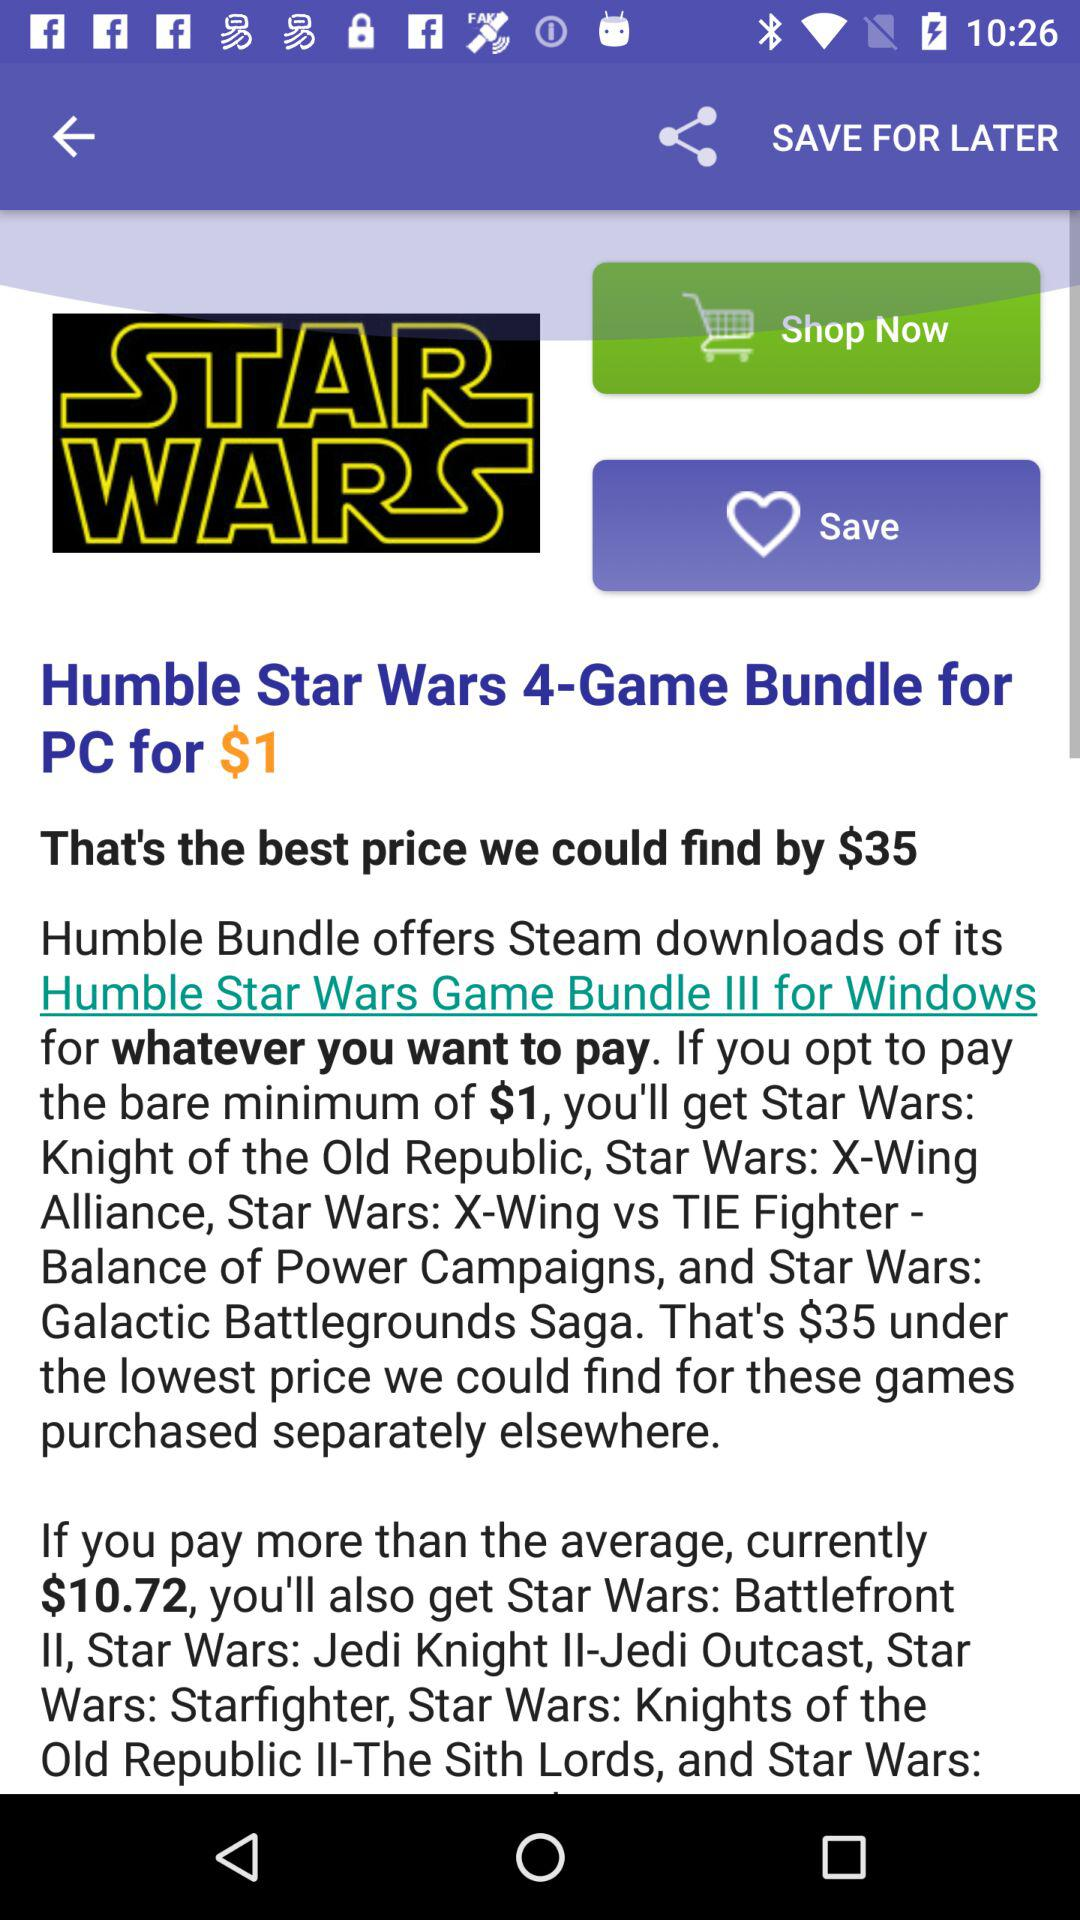What is the best price we could find? The best price you could find is $35. 